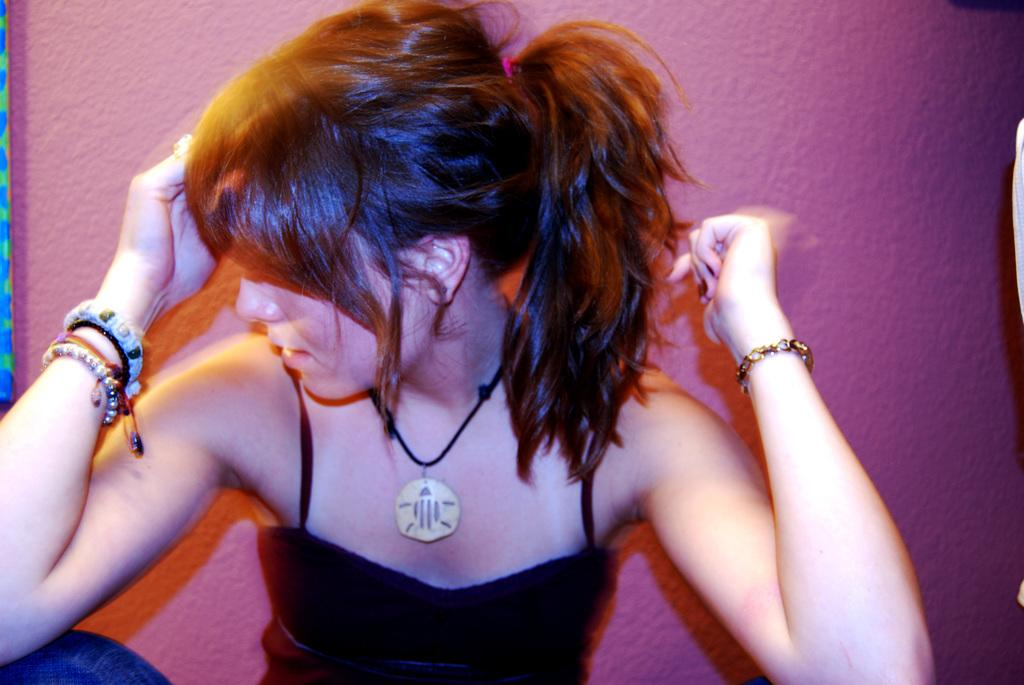Where was the image most likely taken? The image was likely taken indoors. Who is in the image? There is a woman in the image. What is the woman wearing? The woman is wearing a black dress. What is the woman doing in the image? The woman is sitting. What can be seen in the background of the image? There is a wall and other objects in the background of the image. Can you see a bridge in the image? No, there is no bridge present in the image. Is the woman holding a rifle in the image? No, the woman is not holding a rifle in the image. 